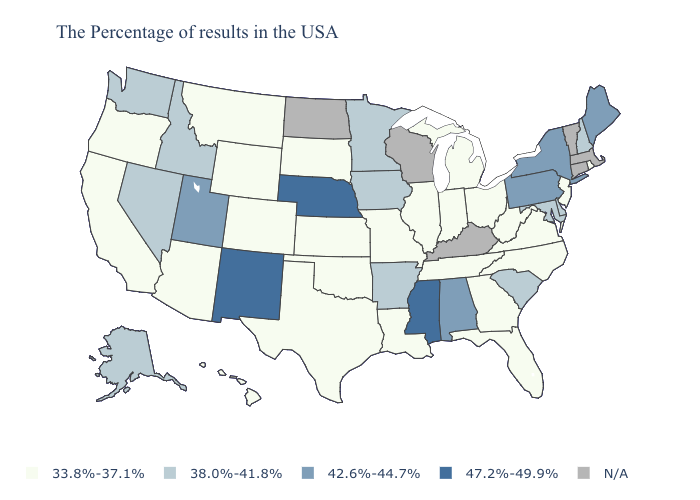Name the states that have a value in the range 33.8%-37.1%?
Short answer required. Rhode Island, New Jersey, Virginia, North Carolina, West Virginia, Ohio, Florida, Georgia, Michigan, Indiana, Tennessee, Illinois, Louisiana, Missouri, Kansas, Oklahoma, Texas, South Dakota, Wyoming, Colorado, Montana, Arizona, California, Oregon, Hawaii. Name the states that have a value in the range N/A?
Be succinct. Massachusetts, Vermont, Connecticut, Kentucky, Wisconsin, North Dakota. What is the lowest value in the USA?
Concise answer only. 33.8%-37.1%. What is the value of Utah?
Quick response, please. 42.6%-44.7%. What is the value of California?
Short answer required. 33.8%-37.1%. Does Idaho have the lowest value in the USA?
Concise answer only. No. How many symbols are there in the legend?
Keep it brief. 5. What is the highest value in states that border Maine?
Answer briefly. 38.0%-41.8%. What is the highest value in the West ?
Quick response, please. 47.2%-49.9%. Does the first symbol in the legend represent the smallest category?
Be succinct. Yes. What is the value of Kentucky?
Be succinct. N/A. Name the states that have a value in the range N/A?
Concise answer only. Massachusetts, Vermont, Connecticut, Kentucky, Wisconsin, North Dakota. Does Arkansas have the lowest value in the USA?
Quick response, please. No. Name the states that have a value in the range 38.0%-41.8%?
Keep it brief. New Hampshire, Delaware, Maryland, South Carolina, Arkansas, Minnesota, Iowa, Idaho, Nevada, Washington, Alaska. 